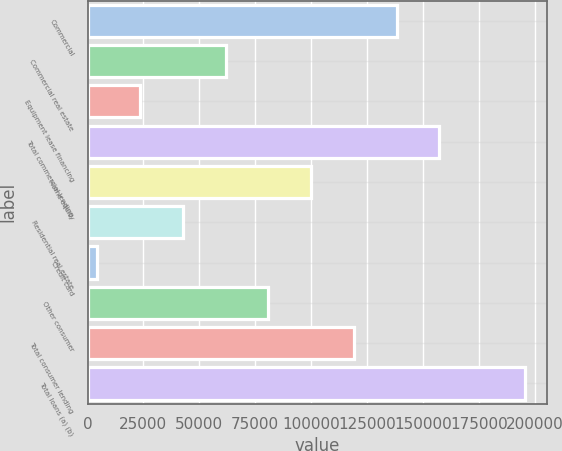<chart> <loc_0><loc_0><loc_500><loc_500><bar_chart><fcel>Commercial<fcel>Commercial real estate<fcel>Equipment lease financing<fcel>Total commercial lending<fcel>Home equity<fcel>Residential real estate<fcel>Credit card<fcel>Other consumer<fcel>Total consumer lending<fcel>Total loans (a) (b)<nl><fcel>138257<fcel>61781.4<fcel>23543.8<fcel>157375<fcel>100019<fcel>42662.6<fcel>4425<fcel>80900.2<fcel>119138<fcel>195613<nl></chart> 